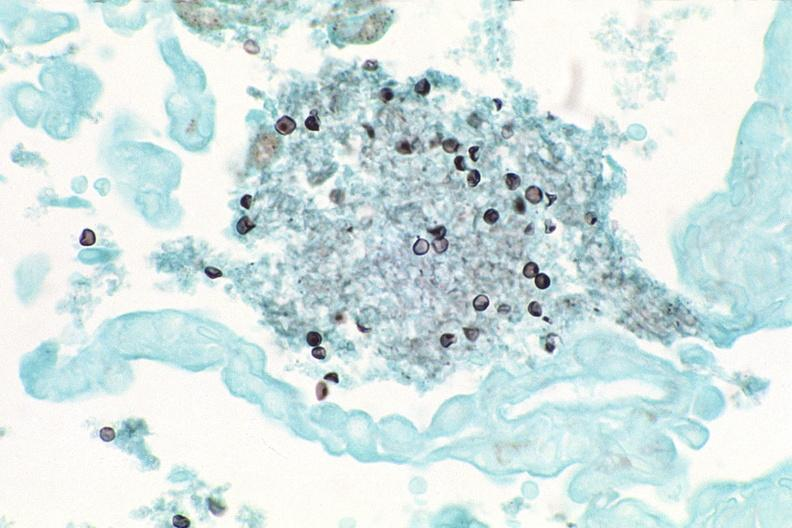does this image show lung, pneumocystis pneumonia?
Answer the question using a single word or phrase. Yes 